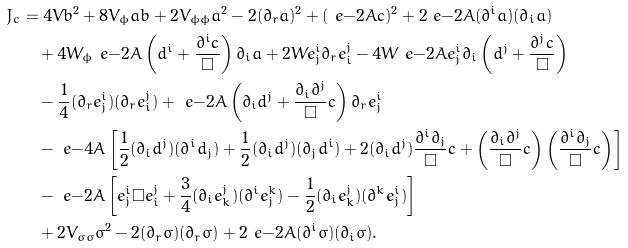Convert formula to latex. <formula><loc_0><loc_0><loc_500><loc_500>J _ { c } & = 4 V b ^ { 2 } + 8 V _ { \phi } a b + 2 V _ { \phi \phi } a ^ { 2 } - 2 ( \partial _ { r } a ) ^ { 2 } + ( \ e { - 2 A } c ) ^ { 2 } + 2 \ e { - 2 A } ( \partial ^ { i } a ) ( \partial _ { i } a ) \\ & \quad + 4 W _ { \phi } \ e { - 2 A } \left ( d ^ { i } + \frac { \partial ^ { i } c } { \Box } \right ) \partial _ { i } a + 2 W e ^ { i } _ { j } \partial _ { r } e ^ { j } _ { i } - 4 W \ e { - 2 A } e ^ { i } _ { j } \partial _ { i } \left ( d ^ { j } + \frac { \partial ^ { j } c } { \Box } \right ) \\ & \quad - \frac { 1 } { 4 } ( \partial _ { r } e ^ { i } _ { j } ) ( \partial _ { r } e ^ { j } _ { i } ) + \ e { - 2 A } \left ( \partial _ { i } d ^ { j } + \frac { \partial _ { i } \partial ^ { j } } { \Box } c \right ) \partial _ { r } e ^ { i } _ { j } \\ & \quad - \ e { - 4 A } \left [ \frac { 1 } { 2 } ( \partial _ { i } d ^ { j } ) ( \partial ^ { i } d _ { j } ) + \frac { 1 } { 2 } ( \partial _ { i } d ^ { j } ) ( \partial _ { j } d ^ { i } ) + 2 ( \partial _ { i } d ^ { j } ) \frac { \partial ^ { i } \partial _ { j } } { \Box } c + \left ( \frac { \partial _ { i } \partial ^ { j } } { \Box } c \right ) \left ( \frac { \partial ^ { i } \partial _ { j } } { \Box } c \right ) \right ] \\ & \quad - \ e { - 2 A } \left [ e ^ { i } _ { j } \Box e ^ { j } _ { i } + \frac { 3 } { 4 } ( \partial _ { i } e ^ { j } _ { k } ) ( \partial ^ { i } e _ { j } ^ { k } ) - \frac { 1 } { 2 } ( \partial _ { i } e ^ { j } _ { k } ) ( \partial ^ { k } e ^ { i } _ { j } ) \right ] \\ & \quad + 2 V _ { \sigma \sigma } \sigma ^ { 2 } - 2 ( \partial _ { r } \sigma ) ( \partial _ { r } \sigma ) + 2 \ e { - 2 A } ( \partial ^ { i } \sigma ) ( \partial _ { i } \sigma ) .</formula> 